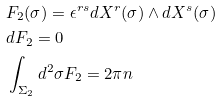Convert formula to latex. <formula><loc_0><loc_0><loc_500><loc_500>& F _ { 2 } ( \sigma ) = \epsilon ^ { r s } d X ^ { r } ( \sigma ) \wedge d X ^ { s } ( \sigma ) \\ & d F _ { 2 } = 0 \\ & \int _ { \Sigma _ { 2 } } d ^ { 2 } \sigma F _ { 2 } = 2 \pi n</formula> 